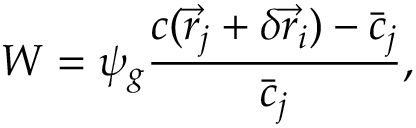Convert formula to latex. <formula><loc_0><loc_0><loc_500><loc_500>W = \psi _ { g } \frac { c ( \vec { r } _ { j } + \delta \vec { r } _ { i } ) - \bar { c } _ { j } } { \bar { c } _ { j } } ,</formula> 